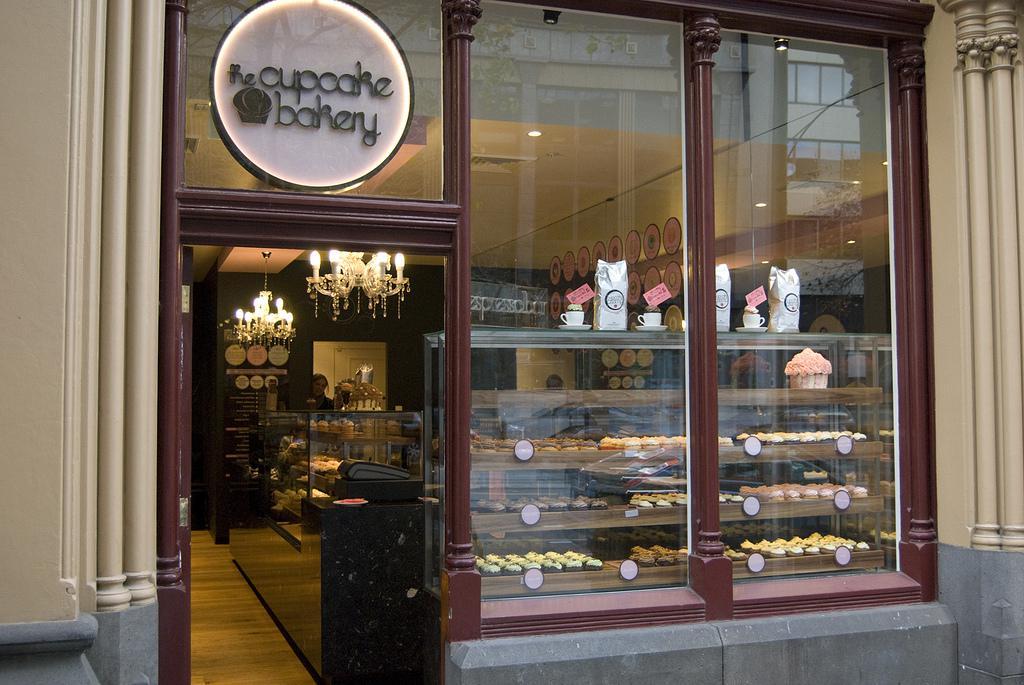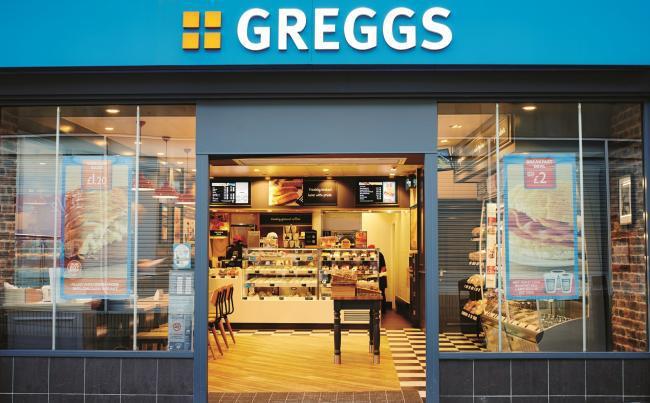The first image is the image on the left, the second image is the image on the right. Assess this claim about the two images: "There is at least one chair outside in front of a building.". Correct or not? Answer yes or no. No. The first image is the image on the left, the second image is the image on the right. Examine the images to the left and right. Is the description "The front door is wide open in some of the pictures." accurate? Answer yes or no. Yes. 